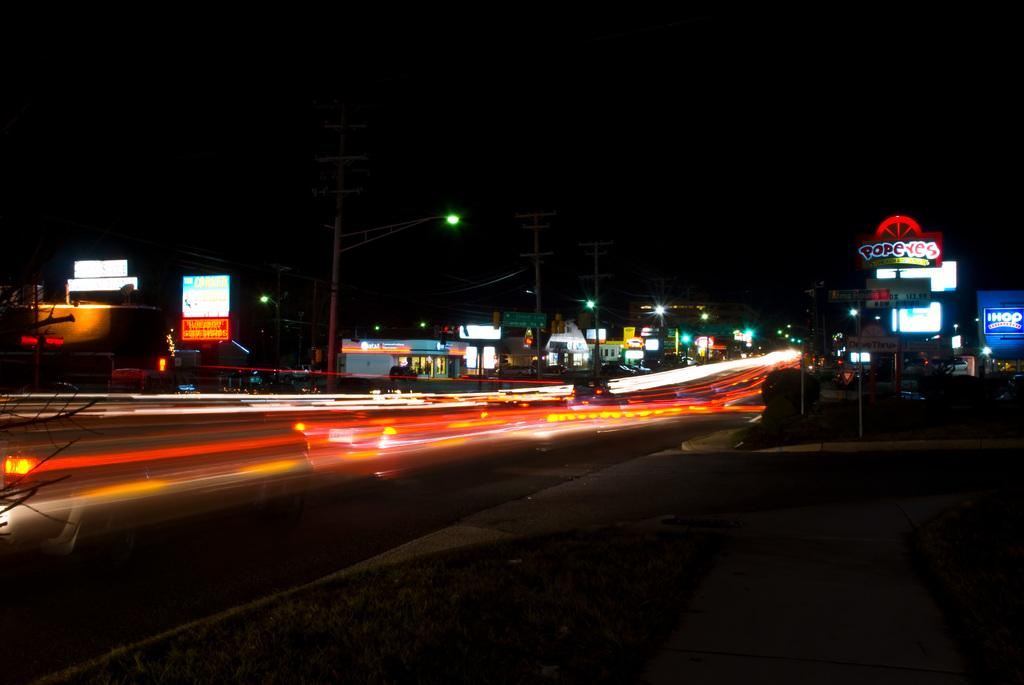What time of day was the image taken? The image was taken at night time. What type of structures can be seen in the image? There are buildings in the image. What are the boards with text used for? The boards with text might be used for advertising or providing information. What are the poles in the image used for? The poles in the image are utility poles, which are used to support electrical wires and other infrastructure. What type of lighting is present in the image? There are street lights in the image. What is the primary surface visible in the image? There is a road in the image. How would you describe the overall appearance of the background in the image? The background of the image is dark. What type of pickle is being served on the sofa in the image? There is no pickle or sofa present in the image. How many fingers can be seen pointing at the utility poles in the image? There are no fingers visible in the image, as it features a nighttime scene with buildings, boards, poles, street lights, and a road. 